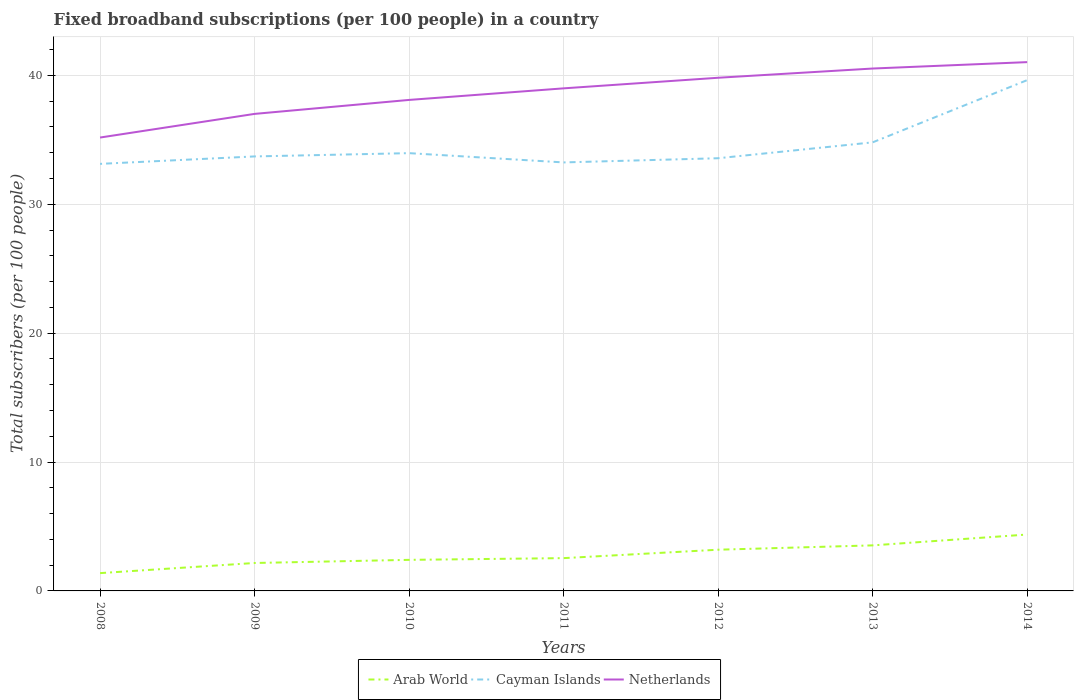How many different coloured lines are there?
Keep it short and to the point. 3. Across all years, what is the maximum number of broadband subscriptions in Netherlands?
Offer a terse response. 35.17. What is the total number of broadband subscriptions in Arab World in the graph?
Your answer should be very brief. -1.03. What is the difference between the highest and the second highest number of broadband subscriptions in Arab World?
Make the answer very short. 2.99. What is the difference between the highest and the lowest number of broadband subscriptions in Netherlands?
Offer a terse response. 4. Is the number of broadband subscriptions in Cayman Islands strictly greater than the number of broadband subscriptions in Arab World over the years?
Offer a terse response. No. How many lines are there?
Ensure brevity in your answer.  3. What is the difference between two consecutive major ticks on the Y-axis?
Provide a short and direct response. 10. Are the values on the major ticks of Y-axis written in scientific E-notation?
Keep it short and to the point. No. Where does the legend appear in the graph?
Provide a succinct answer. Bottom center. How many legend labels are there?
Your answer should be very brief. 3. What is the title of the graph?
Keep it short and to the point. Fixed broadband subscriptions (per 100 people) in a country. Does "Cabo Verde" appear as one of the legend labels in the graph?
Give a very brief answer. No. What is the label or title of the Y-axis?
Make the answer very short. Total subscribers (per 100 people). What is the Total subscribers (per 100 people) of Arab World in 2008?
Give a very brief answer. 1.38. What is the Total subscribers (per 100 people) in Cayman Islands in 2008?
Offer a terse response. 33.13. What is the Total subscribers (per 100 people) in Netherlands in 2008?
Offer a very short reply. 35.17. What is the Total subscribers (per 100 people) of Arab World in 2009?
Provide a succinct answer. 2.17. What is the Total subscribers (per 100 people) in Cayman Islands in 2009?
Offer a terse response. 33.71. What is the Total subscribers (per 100 people) of Netherlands in 2009?
Ensure brevity in your answer.  37.01. What is the Total subscribers (per 100 people) of Arab World in 2010?
Provide a short and direct response. 2.41. What is the Total subscribers (per 100 people) of Cayman Islands in 2010?
Provide a short and direct response. 33.96. What is the Total subscribers (per 100 people) of Netherlands in 2010?
Your answer should be very brief. 38.09. What is the Total subscribers (per 100 people) in Arab World in 2011?
Make the answer very short. 2.54. What is the Total subscribers (per 100 people) of Cayman Islands in 2011?
Your response must be concise. 33.24. What is the Total subscribers (per 100 people) in Netherlands in 2011?
Make the answer very short. 38.99. What is the Total subscribers (per 100 people) in Arab World in 2012?
Your answer should be compact. 3.2. What is the Total subscribers (per 100 people) in Cayman Islands in 2012?
Make the answer very short. 33.57. What is the Total subscribers (per 100 people) in Netherlands in 2012?
Give a very brief answer. 39.81. What is the Total subscribers (per 100 people) of Arab World in 2013?
Ensure brevity in your answer.  3.53. What is the Total subscribers (per 100 people) in Cayman Islands in 2013?
Your answer should be very brief. 34.8. What is the Total subscribers (per 100 people) of Netherlands in 2013?
Provide a short and direct response. 40.53. What is the Total subscribers (per 100 people) in Arab World in 2014?
Provide a short and direct response. 4.37. What is the Total subscribers (per 100 people) of Cayman Islands in 2014?
Make the answer very short. 39.63. What is the Total subscribers (per 100 people) of Netherlands in 2014?
Keep it short and to the point. 41.02. Across all years, what is the maximum Total subscribers (per 100 people) of Arab World?
Provide a short and direct response. 4.37. Across all years, what is the maximum Total subscribers (per 100 people) of Cayman Islands?
Your answer should be compact. 39.63. Across all years, what is the maximum Total subscribers (per 100 people) of Netherlands?
Ensure brevity in your answer.  41.02. Across all years, what is the minimum Total subscribers (per 100 people) of Arab World?
Your response must be concise. 1.38. Across all years, what is the minimum Total subscribers (per 100 people) in Cayman Islands?
Give a very brief answer. 33.13. Across all years, what is the minimum Total subscribers (per 100 people) in Netherlands?
Your answer should be compact. 35.17. What is the total Total subscribers (per 100 people) of Arab World in the graph?
Offer a terse response. 19.61. What is the total Total subscribers (per 100 people) in Cayman Islands in the graph?
Your answer should be very brief. 242.04. What is the total Total subscribers (per 100 people) in Netherlands in the graph?
Offer a very short reply. 270.62. What is the difference between the Total subscribers (per 100 people) in Arab World in 2008 and that in 2009?
Keep it short and to the point. -0.79. What is the difference between the Total subscribers (per 100 people) in Cayman Islands in 2008 and that in 2009?
Keep it short and to the point. -0.58. What is the difference between the Total subscribers (per 100 people) of Netherlands in 2008 and that in 2009?
Give a very brief answer. -1.84. What is the difference between the Total subscribers (per 100 people) in Arab World in 2008 and that in 2010?
Your answer should be very brief. -1.03. What is the difference between the Total subscribers (per 100 people) in Cayman Islands in 2008 and that in 2010?
Provide a short and direct response. -0.83. What is the difference between the Total subscribers (per 100 people) of Netherlands in 2008 and that in 2010?
Offer a terse response. -2.92. What is the difference between the Total subscribers (per 100 people) of Arab World in 2008 and that in 2011?
Ensure brevity in your answer.  -1.16. What is the difference between the Total subscribers (per 100 people) of Cayman Islands in 2008 and that in 2011?
Offer a terse response. -0.11. What is the difference between the Total subscribers (per 100 people) of Netherlands in 2008 and that in 2011?
Offer a terse response. -3.82. What is the difference between the Total subscribers (per 100 people) in Arab World in 2008 and that in 2012?
Your answer should be very brief. -1.82. What is the difference between the Total subscribers (per 100 people) in Cayman Islands in 2008 and that in 2012?
Provide a short and direct response. -0.44. What is the difference between the Total subscribers (per 100 people) in Netherlands in 2008 and that in 2012?
Your answer should be compact. -4.64. What is the difference between the Total subscribers (per 100 people) in Arab World in 2008 and that in 2013?
Offer a terse response. -2.15. What is the difference between the Total subscribers (per 100 people) in Cayman Islands in 2008 and that in 2013?
Provide a short and direct response. -1.67. What is the difference between the Total subscribers (per 100 people) in Netherlands in 2008 and that in 2013?
Offer a terse response. -5.35. What is the difference between the Total subscribers (per 100 people) of Arab World in 2008 and that in 2014?
Provide a short and direct response. -2.99. What is the difference between the Total subscribers (per 100 people) of Cayman Islands in 2008 and that in 2014?
Your answer should be compact. -6.5. What is the difference between the Total subscribers (per 100 people) in Netherlands in 2008 and that in 2014?
Offer a terse response. -5.85. What is the difference between the Total subscribers (per 100 people) of Arab World in 2009 and that in 2010?
Offer a terse response. -0.24. What is the difference between the Total subscribers (per 100 people) of Cayman Islands in 2009 and that in 2010?
Your response must be concise. -0.25. What is the difference between the Total subscribers (per 100 people) in Netherlands in 2009 and that in 2010?
Offer a very short reply. -1.08. What is the difference between the Total subscribers (per 100 people) in Arab World in 2009 and that in 2011?
Offer a very short reply. -0.38. What is the difference between the Total subscribers (per 100 people) of Cayman Islands in 2009 and that in 2011?
Make the answer very short. 0.46. What is the difference between the Total subscribers (per 100 people) of Netherlands in 2009 and that in 2011?
Provide a succinct answer. -1.98. What is the difference between the Total subscribers (per 100 people) of Arab World in 2009 and that in 2012?
Make the answer very short. -1.03. What is the difference between the Total subscribers (per 100 people) of Cayman Islands in 2009 and that in 2012?
Your answer should be compact. 0.14. What is the difference between the Total subscribers (per 100 people) of Netherlands in 2009 and that in 2012?
Offer a terse response. -2.8. What is the difference between the Total subscribers (per 100 people) in Arab World in 2009 and that in 2013?
Give a very brief answer. -1.37. What is the difference between the Total subscribers (per 100 people) of Cayman Islands in 2009 and that in 2013?
Give a very brief answer. -1.09. What is the difference between the Total subscribers (per 100 people) of Netherlands in 2009 and that in 2013?
Provide a succinct answer. -3.52. What is the difference between the Total subscribers (per 100 people) in Arab World in 2009 and that in 2014?
Provide a short and direct response. -2.21. What is the difference between the Total subscribers (per 100 people) of Cayman Islands in 2009 and that in 2014?
Provide a succinct answer. -5.92. What is the difference between the Total subscribers (per 100 people) in Netherlands in 2009 and that in 2014?
Ensure brevity in your answer.  -4.02. What is the difference between the Total subscribers (per 100 people) of Arab World in 2010 and that in 2011?
Offer a terse response. -0.13. What is the difference between the Total subscribers (per 100 people) of Cayman Islands in 2010 and that in 2011?
Make the answer very short. 0.72. What is the difference between the Total subscribers (per 100 people) in Netherlands in 2010 and that in 2011?
Provide a succinct answer. -0.9. What is the difference between the Total subscribers (per 100 people) of Arab World in 2010 and that in 2012?
Keep it short and to the point. -0.79. What is the difference between the Total subscribers (per 100 people) in Cayman Islands in 2010 and that in 2012?
Ensure brevity in your answer.  0.39. What is the difference between the Total subscribers (per 100 people) in Netherlands in 2010 and that in 2012?
Give a very brief answer. -1.72. What is the difference between the Total subscribers (per 100 people) in Arab World in 2010 and that in 2013?
Make the answer very short. -1.12. What is the difference between the Total subscribers (per 100 people) of Cayman Islands in 2010 and that in 2013?
Ensure brevity in your answer.  -0.84. What is the difference between the Total subscribers (per 100 people) in Netherlands in 2010 and that in 2013?
Offer a terse response. -2.44. What is the difference between the Total subscribers (per 100 people) in Arab World in 2010 and that in 2014?
Give a very brief answer. -1.96. What is the difference between the Total subscribers (per 100 people) of Cayman Islands in 2010 and that in 2014?
Offer a very short reply. -5.66. What is the difference between the Total subscribers (per 100 people) in Netherlands in 2010 and that in 2014?
Your response must be concise. -2.93. What is the difference between the Total subscribers (per 100 people) in Arab World in 2011 and that in 2012?
Provide a succinct answer. -0.65. What is the difference between the Total subscribers (per 100 people) in Cayman Islands in 2011 and that in 2012?
Your answer should be very brief. -0.32. What is the difference between the Total subscribers (per 100 people) in Netherlands in 2011 and that in 2012?
Ensure brevity in your answer.  -0.82. What is the difference between the Total subscribers (per 100 people) in Arab World in 2011 and that in 2013?
Your response must be concise. -0.99. What is the difference between the Total subscribers (per 100 people) in Cayman Islands in 2011 and that in 2013?
Your answer should be compact. -1.56. What is the difference between the Total subscribers (per 100 people) in Netherlands in 2011 and that in 2013?
Offer a very short reply. -1.54. What is the difference between the Total subscribers (per 100 people) in Arab World in 2011 and that in 2014?
Make the answer very short. -1.83. What is the difference between the Total subscribers (per 100 people) of Cayman Islands in 2011 and that in 2014?
Your answer should be very brief. -6.38. What is the difference between the Total subscribers (per 100 people) in Netherlands in 2011 and that in 2014?
Your answer should be very brief. -2.03. What is the difference between the Total subscribers (per 100 people) in Arab World in 2012 and that in 2013?
Keep it short and to the point. -0.34. What is the difference between the Total subscribers (per 100 people) in Cayman Islands in 2012 and that in 2013?
Offer a very short reply. -1.23. What is the difference between the Total subscribers (per 100 people) in Netherlands in 2012 and that in 2013?
Provide a succinct answer. -0.72. What is the difference between the Total subscribers (per 100 people) of Arab World in 2012 and that in 2014?
Provide a succinct answer. -1.18. What is the difference between the Total subscribers (per 100 people) of Cayman Islands in 2012 and that in 2014?
Provide a short and direct response. -6.06. What is the difference between the Total subscribers (per 100 people) in Netherlands in 2012 and that in 2014?
Offer a very short reply. -1.21. What is the difference between the Total subscribers (per 100 people) of Arab World in 2013 and that in 2014?
Ensure brevity in your answer.  -0.84. What is the difference between the Total subscribers (per 100 people) of Cayman Islands in 2013 and that in 2014?
Ensure brevity in your answer.  -4.83. What is the difference between the Total subscribers (per 100 people) of Netherlands in 2013 and that in 2014?
Ensure brevity in your answer.  -0.5. What is the difference between the Total subscribers (per 100 people) of Arab World in 2008 and the Total subscribers (per 100 people) of Cayman Islands in 2009?
Provide a succinct answer. -32.33. What is the difference between the Total subscribers (per 100 people) in Arab World in 2008 and the Total subscribers (per 100 people) in Netherlands in 2009?
Ensure brevity in your answer.  -35.63. What is the difference between the Total subscribers (per 100 people) of Cayman Islands in 2008 and the Total subscribers (per 100 people) of Netherlands in 2009?
Provide a succinct answer. -3.88. What is the difference between the Total subscribers (per 100 people) of Arab World in 2008 and the Total subscribers (per 100 people) of Cayman Islands in 2010?
Ensure brevity in your answer.  -32.58. What is the difference between the Total subscribers (per 100 people) of Arab World in 2008 and the Total subscribers (per 100 people) of Netherlands in 2010?
Your response must be concise. -36.71. What is the difference between the Total subscribers (per 100 people) in Cayman Islands in 2008 and the Total subscribers (per 100 people) in Netherlands in 2010?
Offer a very short reply. -4.96. What is the difference between the Total subscribers (per 100 people) in Arab World in 2008 and the Total subscribers (per 100 people) in Cayman Islands in 2011?
Ensure brevity in your answer.  -31.86. What is the difference between the Total subscribers (per 100 people) of Arab World in 2008 and the Total subscribers (per 100 people) of Netherlands in 2011?
Ensure brevity in your answer.  -37.61. What is the difference between the Total subscribers (per 100 people) in Cayman Islands in 2008 and the Total subscribers (per 100 people) in Netherlands in 2011?
Offer a very short reply. -5.86. What is the difference between the Total subscribers (per 100 people) in Arab World in 2008 and the Total subscribers (per 100 people) in Cayman Islands in 2012?
Offer a terse response. -32.19. What is the difference between the Total subscribers (per 100 people) of Arab World in 2008 and the Total subscribers (per 100 people) of Netherlands in 2012?
Ensure brevity in your answer.  -38.43. What is the difference between the Total subscribers (per 100 people) in Cayman Islands in 2008 and the Total subscribers (per 100 people) in Netherlands in 2012?
Your answer should be very brief. -6.68. What is the difference between the Total subscribers (per 100 people) in Arab World in 2008 and the Total subscribers (per 100 people) in Cayman Islands in 2013?
Your answer should be very brief. -33.42. What is the difference between the Total subscribers (per 100 people) of Arab World in 2008 and the Total subscribers (per 100 people) of Netherlands in 2013?
Keep it short and to the point. -39.15. What is the difference between the Total subscribers (per 100 people) in Cayman Islands in 2008 and the Total subscribers (per 100 people) in Netherlands in 2013?
Offer a very short reply. -7.4. What is the difference between the Total subscribers (per 100 people) of Arab World in 2008 and the Total subscribers (per 100 people) of Cayman Islands in 2014?
Your response must be concise. -38.24. What is the difference between the Total subscribers (per 100 people) of Arab World in 2008 and the Total subscribers (per 100 people) of Netherlands in 2014?
Give a very brief answer. -39.64. What is the difference between the Total subscribers (per 100 people) in Cayman Islands in 2008 and the Total subscribers (per 100 people) in Netherlands in 2014?
Offer a very short reply. -7.89. What is the difference between the Total subscribers (per 100 people) in Arab World in 2009 and the Total subscribers (per 100 people) in Cayman Islands in 2010?
Provide a succinct answer. -31.79. What is the difference between the Total subscribers (per 100 people) in Arab World in 2009 and the Total subscribers (per 100 people) in Netherlands in 2010?
Offer a very short reply. -35.92. What is the difference between the Total subscribers (per 100 people) in Cayman Islands in 2009 and the Total subscribers (per 100 people) in Netherlands in 2010?
Your answer should be compact. -4.38. What is the difference between the Total subscribers (per 100 people) of Arab World in 2009 and the Total subscribers (per 100 people) of Cayman Islands in 2011?
Ensure brevity in your answer.  -31.08. What is the difference between the Total subscribers (per 100 people) in Arab World in 2009 and the Total subscribers (per 100 people) in Netherlands in 2011?
Your response must be concise. -36.82. What is the difference between the Total subscribers (per 100 people) of Cayman Islands in 2009 and the Total subscribers (per 100 people) of Netherlands in 2011?
Offer a very short reply. -5.28. What is the difference between the Total subscribers (per 100 people) in Arab World in 2009 and the Total subscribers (per 100 people) in Cayman Islands in 2012?
Keep it short and to the point. -31.4. What is the difference between the Total subscribers (per 100 people) in Arab World in 2009 and the Total subscribers (per 100 people) in Netherlands in 2012?
Your answer should be compact. -37.64. What is the difference between the Total subscribers (per 100 people) of Cayman Islands in 2009 and the Total subscribers (per 100 people) of Netherlands in 2012?
Offer a very short reply. -6.1. What is the difference between the Total subscribers (per 100 people) in Arab World in 2009 and the Total subscribers (per 100 people) in Cayman Islands in 2013?
Your response must be concise. -32.63. What is the difference between the Total subscribers (per 100 people) in Arab World in 2009 and the Total subscribers (per 100 people) in Netherlands in 2013?
Ensure brevity in your answer.  -38.36. What is the difference between the Total subscribers (per 100 people) of Cayman Islands in 2009 and the Total subscribers (per 100 people) of Netherlands in 2013?
Offer a very short reply. -6.82. What is the difference between the Total subscribers (per 100 people) in Arab World in 2009 and the Total subscribers (per 100 people) in Cayman Islands in 2014?
Offer a terse response. -37.46. What is the difference between the Total subscribers (per 100 people) in Arab World in 2009 and the Total subscribers (per 100 people) in Netherlands in 2014?
Your answer should be very brief. -38.86. What is the difference between the Total subscribers (per 100 people) in Cayman Islands in 2009 and the Total subscribers (per 100 people) in Netherlands in 2014?
Offer a terse response. -7.32. What is the difference between the Total subscribers (per 100 people) in Arab World in 2010 and the Total subscribers (per 100 people) in Cayman Islands in 2011?
Ensure brevity in your answer.  -30.83. What is the difference between the Total subscribers (per 100 people) in Arab World in 2010 and the Total subscribers (per 100 people) in Netherlands in 2011?
Offer a terse response. -36.58. What is the difference between the Total subscribers (per 100 people) in Cayman Islands in 2010 and the Total subscribers (per 100 people) in Netherlands in 2011?
Keep it short and to the point. -5.03. What is the difference between the Total subscribers (per 100 people) of Arab World in 2010 and the Total subscribers (per 100 people) of Cayman Islands in 2012?
Keep it short and to the point. -31.16. What is the difference between the Total subscribers (per 100 people) of Arab World in 2010 and the Total subscribers (per 100 people) of Netherlands in 2012?
Offer a very short reply. -37.4. What is the difference between the Total subscribers (per 100 people) in Cayman Islands in 2010 and the Total subscribers (per 100 people) in Netherlands in 2012?
Provide a succinct answer. -5.85. What is the difference between the Total subscribers (per 100 people) in Arab World in 2010 and the Total subscribers (per 100 people) in Cayman Islands in 2013?
Make the answer very short. -32.39. What is the difference between the Total subscribers (per 100 people) of Arab World in 2010 and the Total subscribers (per 100 people) of Netherlands in 2013?
Offer a very short reply. -38.12. What is the difference between the Total subscribers (per 100 people) of Cayman Islands in 2010 and the Total subscribers (per 100 people) of Netherlands in 2013?
Provide a succinct answer. -6.56. What is the difference between the Total subscribers (per 100 people) in Arab World in 2010 and the Total subscribers (per 100 people) in Cayman Islands in 2014?
Your answer should be compact. -37.22. What is the difference between the Total subscribers (per 100 people) of Arab World in 2010 and the Total subscribers (per 100 people) of Netherlands in 2014?
Give a very brief answer. -38.61. What is the difference between the Total subscribers (per 100 people) of Cayman Islands in 2010 and the Total subscribers (per 100 people) of Netherlands in 2014?
Your answer should be very brief. -7.06. What is the difference between the Total subscribers (per 100 people) of Arab World in 2011 and the Total subscribers (per 100 people) of Cayman Islands in 2012?
Provide a succinct answer. -31.02. What is the difference between the Total subscribers (per 100 people) of Arab World in 2011 and the Total subscribers (per 100 people) of Netherlands in 2012?
Make the answer very short. -37.27. What is the difference between the Total subscribers (per 100 people) of Cayman Islands in 2011 and the Total subscribers (per 100 people) of Netherlands in 2012?
Offer a very short reply. -6.57. What is the difference between the Total subscribers (per 100 people) of Arab World in 2011 and the Total subscribers (per 100 people) of Cayman Islands in 2013?
Provide a succinct answer. -32.26. What is the difference between the Total subscribers (per 100 people) of Arab World in 2011 and the Total subscribers (per 100 people) of Netherlands in 2013?
Your answer should be very brief. -37.98. What is the difference between the Total subscribers (per 100 people) of Cayman Islands in 2011 and the Total subscribers (per 100 people) of Netherlands in 2013?
Keep it short and to the point. -7.28. What is the difference between the Total subscribers (per 100 people) of Arab World in 2011 and the Total subscribers (per 100 people) of Cayman Islands in 2014?
Make the answer very short. -37.08. What is the difference between the Total subscribers (per 100 people) of Arab World in 2011 and the Total subscribers (per 100 people) of Netherlands in 2014?
Your response must be concise. -38.48. What is the difference between the Total subscribers (per 100 people) in Cayman Islands in 2011 and the Total subscribers (per 100 people) in Netherlands in 2014?
Offer a very short reply. -7.78. What is the difference between the Total subscribers (per 100 people) of Arab World in 2012 and the Total subscribers (per 100 people) of Cayman Islands in 2013?
Your answer should be very brief. -31.6. What is the difference between the Total subscribers (per 100 people) in Arab World in 2012 and the Total subscribers (per 100 people) in Netherlands in 2013?
Keep it short and to the point. -37.33. What is the difference between the Total subscribers (per 100 people) of Cayman Islands in 2012 and the Total subscribers (per 100 people) of Netherlands in 2013?
Provide a short and direct response. -6.96. What is the difference between the Total subscribers (per 100 people) of Arab World in 2012 and the Total subscribers (per 100 people) of Cayman Islands in 2014?
Ensure brevity in your answer.  -36.43. What is the difference between the Total subscribers (per 100 people) in Arab World in 2012 and the Total subscribers (per 100 people) in Netherlands in 2014?
Keep it short and to the point. -37.83. What is the difference between the Total subscribers (per 100 people) in Cayman Islands in 2012 and the Total subscribers (per 100 people) in Netherlands in 2014?
Ensure brevity in your answer.  -7.46. What is the difference between the Total subscribers (per 100 people) in Arab World in 2013 and the Total subscribers (per 100 people) in Cayman Islands in 2014?
Provide a short and direct response. -36.09. What is the difference between the Total subscribers (per 100 people) of Arab World in 2013 and the Total subscribers (per 100 people) of Netherlands in 2014?
Your answer should be compact. -37.49. What is the difference between the Total subscribers (per 100 people) in Cayman Islands in 2013 and the Total subscribers (per 100 people) in Netherlands in 2014?
Offer a terse response. -6.22. What is the average Total subscribers (per 100 people) in Arab World per year?
Provide a short and direct response. 2.8. What is the average Total subscribers (per 100 people) of Cayman Islands per year?
Offer a terse response. 34.58. What is the average Total subscribers (per 100 people) of Netherlands per year?
Ensure brevity in your answer.  38.66. In the year 2008, what is the difference between the Total subscribers (per 100 people) in Arab World and Total subscribers (per 100 people) in Cayman Islands?
Provide a succinct answer. -31.75. In the year 2008, what is the difference between the Total subscribers (per 100 people) in Arab World and Total subscribers (per 100 people) in Netherlands?
Your response must be concise. -33.79. In the year 2008, what is the difference between the Total subscribers (per 100 people) in Cayman Islands and Total subscribers (per 100 people) in Netherlands?
Offer a terse response. -2.04. In the year 2009, what is the difference between the Total subscribers (per 100 people) of Arab World and Total subscribers (per 100 people) of Cayman Islands?
Make the answer very short. -31.54. In the year 2009, what is the difference between the Total subscribers (per 100 people) of Arab World and Total subscribers (per 100 people) of Netherlands?
Keep it short and to the point. -34.84. In the year 2009, what is the difference between the Total subscribers (per 100 people) in Cayman Islands and Total subscribers (per 100 people) in Netherlands?
Give a very brief answer. -3.3. In the year 2010, what is the difference between the Total subscribers (per 100 people) in Arab World and Total subscribers (per 100 people) in Cayman Islands?
Your response must be concise. -31.55. In the year 2010, what is the difference between the Total subscribers (per 100 people) of Arab World and Total subscribers (per 100 people) of Netherlands?
Keep it short and to the point. -35.68. In the year 2010, what is the difference between the Total subscribers (per 100 people) in Cayman Islands and Total subscribers (per 100 people) in Netherlands?
Offer a terse response. -4.13. In the year 2011, what is the difference between the Total subscribers (per 100 people) in Arab World and Total subscribers (per 100 people) in Cayman Islands?
Offer a terse response. -30.7. In the year 2011, what is the difference between the Total subscribers (per 100 people) of Arab World and Total subscribers (per 100 people) of Netherlands?
Give a very brief answer. -36.45. In the year 2011, what is the difference between the Total subscribers (per 100 people) in Cayman Islands and Total subscribers (per 100 people) in Netherlands?
Make the answer very short. -5.75. In the year 2012, what is the difference between the Total subscribers (per 100 people) of Arab World and Total subscribers (per 100 people) of Cayman Islands?
Make the answer very short. -30.37. In the year 2012, what is the difference between the Total subscribers (per 100 people) in Arab World and Total subscribers (per 100 people) in Netherlands?
Give a very brief answer. -36.61. In the year 2012, what is the difference between the Total subscribers (per 100 people) in Cayman Islands and Total subscribers (per 100 people) in Netherlands?
Provide a short and direct response. -6.24. In the year 2013, what is the difference between the Total subscribers (per 100 people) of Arab World and Total subscribers (per 100 people) of Cayman Islands?
Offer a very short reply. -31.27. In the year 2013, what is the difference between the Total subscribers (per 100 people) of Arab World and Total subscribers (per 100 people) of Netherlands?
Offer a terse response. -36.99. In the year 2013, what is the difference between the Total subscribers (per 100 people) of Cayman Islands and Total subscribers (per 100 people) of Netherlands?
Provide a short and direct response. -5.73. In the year 2014, what is the difference between the Total subscribers (per 100 people) in Arab World and Total subscribers (per 100 people) in Cayman Islands?
Your answer should be very brief. -35.25. In the year 2014, what is the difference between the Total subscribers (per 100 people) in Arab World and Total subscribers (per 100 people) in Netherlands?
Make the answer very short. -36.65. In the year 2014, what is the difference between the Total subscribers (per 100 people) in Cayman Islands and Total subscribers (per 100 people) in Netherlands?
Make the answer very short. -1.4. What is the ratio of the Total subscribers (per 100 people) in Arab World in 2008 to that in 2009?
Your answer should be compact. 0.64. What is the ratio of the Total subscribers (per 100 people) of Cayman Islands in 2008 to that in 2009?
Provide a short and direct response. 0.98. What is the ratio of the Total subscribers (per 100 people) in Netherlands in 2008 to that in 2009?
Your response must be concise. 0.95. What is the ratio of the Total subscribers (per 100 people) of Arab World in 2008 to that in 2010?
Keep it short and to the point. 0.57. What is the ratio of the Total subscribers (per 100 people) of Cayman Islands in 2008 to that in 2010?
Your answer should be very brief. 0.98. What is the ratio of the Total subscribers (per 100 people) in Netherlands in 2008 to that in 2010?
Your answer should be compact. 0.92. What is the ratio of the Total subscribers (per 100 people) of Arab World in 2008 to that in 2011?
Offer a terse response. 0.54. What is the ratio of the Total subscribers (per 100 people) in Netherlands in 2008 to that in 2011?
Your response must be concise. 0.9. What is the ratio of the Total subscribers (per 100 people) in Arab World in 2008 to that in 2012?
Provide a succinct answer. 0.43. What is the ratio of the Total subscribers (per 100 people) in Netherlands in 2008 to that in 2012?
Provide a succinct answer. 0.88. What is the ratio of the Total subscribers (per 100 people) in Arab World in 2008 to that in 2013?
Keep it short and to the point. 0.39. What is the ratio of the Total subscribers (per 100 people) in Cayman Islands in 2008 to that in 2013?
Keep it short and to the point. 0.95. What is the ratio of the Total subscribers (per 100 people) in Netherlands in 2008 to that in 2013?
Your answer should be very brief. 0.87. What is the ratio of the Total subscribers (per 100 people) of Arab World in 2008 to that in 2014?
Keep it short and to the point. 0.32. What is the ratio of the Total subscribers (per 100 people) of Cayman Islands in 2008 to that in 2014?
Offer a terse response. 0.84. What is the ratio of the Total subscribers (per 100 people) of Netherlands in 2008 to that in 2014?
Offer a terse response. 0.86. What is the ratio of the Total subscribers (per 100 people) in Arab World in 2009 to that in 2010?
Keep it short and to the point. 0.9. What is the ratio of the Total subscribers (per 100 people) in Netherlands in 2009 to that in 2010?
Your answer should be very brief. 0.97. What is the ratio of the Total subscribers (per 100 people) in Arab World in 2009 to that in 2011?
Provide a short and direct response. 0.85. What is the ratio of the Total subscribers (per 100 people) in Netherlands in 2009 to that in 2011?
Offer a terse response. 0.95. What is the ratio of the Total subscribers (per 100 people) of Arab World in 2009 to that in 2012?
Give a very brief answer. 0.68. What is the ratio of the Total subscribers (per 100 people) in Cayman Islands in 2009 to that in 2012?
Provide a short and direct response. 1. What is the ratio of the Total subscribers (per 100 people) of Netherlands in 2009 to that in 2012?
Provide a short and direct response. 0.93. What is the ratio of the Total subscribers (per 100 people) of Arab World in 2009 to that in 2013?
Make the answer very short. 0.61. What is the ratio of the Total subscribers (per 100 people) of Cayman Islands in 2009 to that in 2013?
Provide a short and direct response. 0.97. What is the ratio of the Total subscribers (per 100 people) in Netherlands in 2009 to that in 2013?
Your answer should be compact. 0.91. What is the ratio of the Total subscribers (per 100 people) in Arab World in 2009 to that in 2014?
Your answer should be very brief. 0.5. What is the ratio of the Total subscribers (per 100 people) in Cayman Islands in 2009 to that in 2014?
Make the answer very short. 0.85. What is the ratio of the Total subscribers (per 100 people) in Netherlands in 2009 to that in 2014?
Offer a very short reply. 0.9. What is the ratio of the Total subscribers (per 100 people) of Arab World in 2010 to that in 2011?
Provide a succinct answer. 0.95. What is the ratio of the Total subscribers (per 100 people) in Cayman Islands in 2010 to that in 2011?
Your response must be concise. 1.02. What is the ratio of the Total subscribers (per 100 people) in Netherlands in 2010 to that in 2011?
Give a very brief answer. 0.98. What is the ratio of the Total subscribers (per 100 people) of Arab World in 2010 to that in 2012?
Offer a very short reply. 0.75. What is the ratio of the Total subscribers (per 100 people) in Cayman Islands in 2010 to that in 2012?
Your response must be concise. 1.01. What is the ratio of the Total subscribers (per 100 people) of Netherlands in 2010 to that in 2012?
Give a very brief answer. 0.96. What is the ratio of the Total subscribers (per 100 people) of Arab World in 2010 to that in 2013?
Ensure brevity in your answer.  0.68. What is the ratio of the Total subscribers (per 100 people) in Cayman Islands in 2010 to that in 2013?
Keep it short and to the point. 0.98. What is the ratio of the Total subscribers (per 100 people) in Netherlands in 2010 to that in 2013?
Offer a terse response. 0.94. What is the ratio of the Total subscribers (per 100 people) in Arab World in 2010 to that in 2014?
Keep it short and to the point. 0.55. What is the ratio of the Total subscribers (per 100 people) of Netherlands in 2010 to that in 2014?
Ensure brevity in your answer.  0.93. What is the ratio of the Total subscribers (per 100 people) in Arab World in 2011 to that in 2012?
Offer a very short reply. 0.8. What is the ratio of the Total subscribers (per 100 people) of Cayman Islands in 2011 to that in 2012?
Ensure brevity in your answer.  0.99. What is the ratio of the Total subscribers (per 100 people) in Netherlands in 2011 to that in 2012?
Ensure brevity in your answer.  0.98. What is the ratio of the Total subscribers (per 100 people) in Arab World in 2011 to that in 2013?
Offer a very short reply. 0.72. What is the ratio of the Total subscribers (per 100 people) in Cayman Islands in 2011 to that in 2013?
Ensure brevity in your answer.  0.96. What is the ratio of the Total subscribers (per 100 people) of Netherlands in 2011 to that in 2013?
Your answer should be compact. 0.96. What is the ratio of the Total subscribers (per 100 people) in Arab World in 2011 to that in 2014?
Your response must be concise. 0.58. What is the ratio of the Total subscribers (per 100 people) in Cayman Islands in 2011 to that in 2014?
Your answer should be compact. 0.84. What is the ratio of the Total subscribers (per 100 people) of Netherlands in 2011 to that in 2014?
Offer a very short reply. 0.95. What is the ratio of the Total subscribers (per 100 people) of Arab World in 2012 to that in 2013?
Your answer should be compact. 0.9. What is the ratio of the Total subscribers (per 100 people) in Cayman Islands in 2012 to that in 2013?
Provide a succinct answer. 0.96. What is the ratio of the Total subscribers (per 100 people) in Netherlands in 2012 to that in 2013?
Make the answer very short. 0.98. What is the ratio of the Total subscribers (per 100 people) of Arab World in 2012 to that in 2014?
Keep it short and to the point. 0.73. What is the ratio of the Total subscribers (per 100 people) of Cayman Islands in 2012 to that in 2014?
Your answer should be very brief. 0.85. What is the ratio of the Total subscribers (per 100 people) of Netherlands in 2012 to that in 2014?
Your answer should be compact. 0.97. What is the ratio of the Total subscribers (per 100 people) in Arab World in 2013 to that in 2014?
Provide a short and direct response. 0.81. What is the ratio of the Total subscribers (per 100 people) of Cayman Islands in 2013 to that in 2014?
Ensure brevity in your answer.  0.88. What is the ratio of the Total subscribers (per 100 people) of Netherlands in 2013 to that in 2014?
Give a very brief answer. 0.99. What is the difference between the highest and the second highest Total subscribers (per 100 people) of Arab World?
Provide a succinct answer. 0.84. What is the difference between the highest and the second highest Total subscribers (per 100 people) of Cayman Islands?
Your answer should be very brief. 4.83. What is the difference between the highest and the second highest Total subscribers (per 100 people) in Netherlands?
Offer a very short reply. 0.5. What is the difference between the highest and the lowest Total subscribers (per 100 people) of Arab World?
Provide a succinct answer. 2.99. What is the difference between the highest and the lowest Total subscribers (per 100 people) in Cayman Islands?
Ensure brevity in your answer.  6.5. What is the difference between the highest and the lowest Total subscribers (per 100 people) of Netherlands?
Make the answer very short. 5.85. 